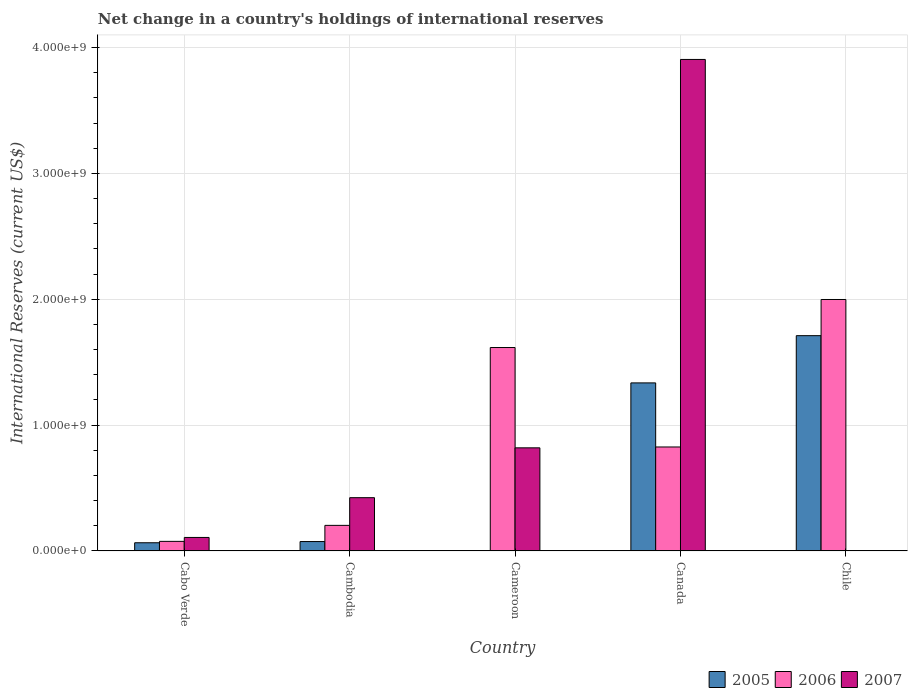How many different coloured bars are there?
Ensure brevity in your answer.  3. Are the number of bars per tick equal to the number of legend labels?
Provide a short and direct response. No. Are the number of bars on each tick of the X-axis equal?
Provide a succinct answer. No. How many bars are there on the 4th tick from the left?
Your answer should be compact. 3. How many bars are there on the 5th tick from the right?
Your answer should be compact. 3. What is the label of the 3rd group of bars from the left?
Your response must be concise. Cameroon. What is the international reserves in 2006 in Cabo Verde?
Your answer should be very brief. 7.60e+07. Across all countries, what is the maximum international reserves in 2005?
Offer a very short reply. 1.71e+09. Across all countries, what is the minimum international reserves in 2005?
Keep it short and to the point. 0. What is the total international reserves in 2005 in the graph?
Offer a very short reply. 3.19e+09. What is the difference between the international reserves in 2007 in Cambodia and that in Canada?
Keep it short and to the point. -3.48e+09. What is the difference between the international reserves in 2006 in Chile and the international reserves in 2007 in Canada?
Your answer should be very brief. -1.91e+09. What is the average international reserves in 2005 per country?
Your answer should be very brief. 6.37e+08. What is the difference between the international reserves of/in 2007 and international reserves of/in 2005 in Cambodia?
Give a very brief answer. 3.49e+08. In how many countries, is the international reserves in 2005 greater than 3800000000 US$?
Provide a short and direct response. 0. What is the ratio of the international reserves in 2006 in Canada to that in Chile?
Provide a short and direct response. 0.41. Is the international reserves in 2006 in Cabo Verde less than that in Chile?
Give a very brief answer. Yes. What is the difference between the highest and the second highest international reserves in 2006?
Give a very brief answer. 1.17e+09. What is the difference between the highest and the lowest international reserves in 2007?
Your answer should be compact. 3.91e+09. In how many countries, is the international reserves in 2006 greater than the average international reserves in 2006 taken over all countries?
Your response must be concise. 2. Is the sum of the international reserves in 2005 in Canada and Chile greater than the maximum international reserves in 2006 across all countries?
Offer a terse response. Yes. Is it the case that in every country, the sum of the international reserves in 2005 and international reserves in 2006 is greater than the international reserves in 2007?
Give a very brief answer. No. Where does the legend appear in the graph?
Your answer should be very brief. Bottom right. How many legend labels are there?
Your answer should be very brief. 3. How are the legend labels stacked?
Your answer should be compact. Horizontal. What is the title of the graph?
Offer a terse response. Net change in a country's holdings of international reserves. Does "1967" appear as one of the legend labels in the graph?
Offer a very short reply. No. What is the label or title of the Y-axis?
Offer a terse response. International Reserves (current US$). What is the International Reserves (current US$) in 2005 in Cabo Verde?
Your response must be concise. 6.49e+07. What is the International Reserves (current US$) in 2006 in Cabo Verde?
Your answer should be very brief. 7.60e+07. What is the International Reserves (current US$) of 2007 in Cabo Verde?
Your answer should be compact. 1.07e+08. What is the International Reserves (current US$) in 2005 in Cambodia?
Offer a very short reply. 7.45e+07. What is the International Reserves (current US$) in 2006 in Cambodia?
Your answer should be very brief. 2.03e+08. What is the International Reserves (current US$) of 2007 in Cambodia?
Keep it short and to the point. 4.23e+08. What is the International Reserves (current US$) of 2005 in Cameroon?
Keep it short and to the point. 0. What is the International Reserves (current US$) of 2006 in Cameroon?
Make the answer very short. 1.62e+09. What is the International Reserves (current US$) in 2007 in Cameroon?
Your response must be concise. 8.19e+08. What is the International Reserves (current US$) in 2005 in Canada?
Provide a short and direct response. 1.34e+09. What is the International Reserves (current US$) in 2006 in Canada?
Ensure brevity in your answer.  8.26e+08. What is the International Reserves (current US$) of 2007 in Canada?
Your response must be concise. 3.91e+09. What is the International Reserves (current US$) of 2005 in Chile?
Offer a very short reply. 1.71e+09. What is the International Reserves (current US$) in 2006 in Chile?
Ensure brevity in your answer.  2.00e+09. Across all countries, what is the maximum International Reserves (current US$) in 2005?
Make the answer very short. 1.71e+09. Across all countries, what is the maximum International Reserves (current US$) of 2006?
Your answer should be compact. 2.00e+09. Across all countries, what is the maximum International Reserves (current US$) of 2007?
Offer a very short reply. 3.91e+09. Across all countries, what is the minimum International Reserves (current US$) in 2006?
Make the answer very short. 7.60e+07. Across all countries, what is the minimum International Reserves (current US$) in 2007?
Give a very brief answer. 0. What is the total International Reserves (current US$) of 2005 in the graph?
Offer a very short reply. 3.19e+09. What is the total International Reserves (current US$) of 2006 in the graph?
Your response must be concise. 4.72e+09. What is the total International Reserves (current US$) of 2007 in the graph?
Offer a terse response. 5.26e+09. What is the difference between the International Reserves (current US$) of 2005 in Cabo Verde and that in Cambodia?
Offer a very short reply. -9.54e+06. What is the difference between the International Reserves (current US$) of 2006 in Cabo Verde and that in Cambodia?
Ensure brevity in your answer.  -1.27e+08. What is the difference between the International Reserves (current US$) in 2007 in Cabo Verde and that in Cambodia?
Your answer should be very brief. -3.16e+08. What is the difference between the International Reserves (current US$) of 2006 in Cabo Verde and that in Cameroon?
Provide a succinct answer. -1.54e+09. What is the difference between the International Reserves (current US$) in 2007 in Cabo Verde and that in Cameroon?
Your answer should be compact. -7.12e+08. What is the difference between the International Reserves (current US$) in 2005 in Cabo Verde and that in Canada?
Ensure brevity in your answer.  -1.27e+09. What is the difference between the International Reserves (current US$) of 2006 in Cabo Verde and that in Canada?
Your answer should be compact. -7.50e+08. What is the difference between the International Reserves (current US$) of 2007 in Cabo Verde and that in Canada?
Make the answer very short. -3.80e+09. What is the difference between the International Reserves (current US$) in 2005 in Cabo Verde and that in Chile?
Offer a terse response. -1.65e+09. What is the difference between the International Reserves (current US$) in 2006 in Cabo Verde and that in Chile?
Your answer should be very brief. -1.92e+09. What is the difference between the International Reserves (current US$) in 2006 in Cambodia and that in Cameroon?
Offer a terse response. -1.41e+09. What is the difference between the International Reserves (current US$) of 2007 in Cambodia and that in Cameroon?
Offer a very short reply. -3.96e+08. What is the difference between the International Reserves (current US$) of 2005 in Cambodia and that in Canada?
Offer a terse response. -1.26e+09. What is the difference between the International Reserves (current US$) in 2006 in Cambodia and that in Canada?
Your answer should be very brief. -6.23e+08. What is the difference between the International Reserves (current US$) of 2007 in Cambodia and that in Canada?
Give a very brief answer. -3.48e+09. What is the difference between the International Reserves (current US$) of 2005 in Cambodia and that in Chile?
Provide a succinct answer. -1.64e+09. What is the difference between the International Reserves (current US$) of 2006 in Cambodia and that in Chile?
Give a very brief answer. -1.80e+09. What is the difference between the International Reserves (current US$) of 2006 in Cameroon and that in Canada?
Provide a succinct answer. 7.90e+08. What is the difference between the International Reserves (current US$) in 2007 in Cameroon and that in Canada?
Make the answer very short. -3.09e+09. What is the difference between the International Reserves (current US$) in 2006 in Cameroon and that in Chile?
Your answer should be compact. -3.82e+08. What is the difference between the International Reserves (current US$) of 2005 in Canada and that in Chile?
Your response must be concise. -3.75e+08. What is the difference between the International Reserves (current US$) in 2006 in Canada and that in Chile?
Your answer should be very brief. -1.17e+09. What is the difference between the International Reserves (current US$) of 2005 in Cabo Verde and the International Reserves (current US$) of 2006 in Cambodia?
Keep it short and to the point. -1.38e+08. What is the difference between the International Reserves (current US$) in 2005 in Cabo Verde and the International Reserves (current US$) in 2007 in Cambodia?
Offer a very short reply. -3.58e+08. What is the difference between the International Reserves (current US$) of 2006 in Cabo Verde and the International Reserves (current US$) of 2007 in Cambodia?
Offer a terse response. -3.47e+08. What is the difference between the International Reserves (current US$) in 2005 in Cabo Verde and the International Reserves (current US$) in 2006 in Cameroon?
Make the answer very short. -1.55e+09. What is the difference between the International Reserves (current US$) in 2005 in Cabo Verde and the International Reserves (current US$) in 2007 in Cameroon?
Give a very brief answer. -7.54e+08. What is the difference between the International Reserves (current US$) in 2006 in Cabo Verde and the International Reserves (current US$) in 2007 in Cameroon?
Provide a succinct answer. -7.43e+08. What is the difference between the International Reserves (current US$) in 2005 in Cabo Verde and the International Reserves (current US$) in 2006 in Canada?
Offer a very short reply. -7.61e+08. What is the difference between the International Reserves (current US$) in 2005 in Cabo Verde and the International Reserves (current US$) in 2007 in Canada?
Ensure brevity in your answer.  -3.84e+09. What is the difference between the International Reserves (current US$) in 2006 in Cabo Verde and the International Reserves (current US$) in 2007 in Canada?
Your answer should be compact. -3.83e+09. What is the difference between the International Reserves (current US$) of 2005 in Cabo Verde and the International Reserves (current US$) of 2006 in Chile?
Your response must be concise. -1.93e+09. What is the difference between the International Reserves (current US$) in 2005 in Cambodia and the International Reserves (current US$) in 2006 in Cameroon?
Offer a very short reply. -1.54e+09. What is the difference between the International Reserves (current US$) of 2005 in Cambodia and the International Reserves (current US$) of 2007 in Cameroon?
Keep it short and to the point. -7.45e+08. What is the difference between the International Reserves (current US$) in 2006 in Cambodia and the International Reserves (current US$) in 2007 in Cameroon?
Keep it short and to the point. -6.16e+08. What is the difference between the International Reserves (current US$) of 2005 in Cambodia and the International Reserves (current US$) of 2006 in Canada?
Make the answer very short. -7.52e+08. What is the difference between the International Reserves (current US$) in 2005 in Cambodia and the International Reserves (current US$) in 2007 in Canada?
Offer a very short reply. -3.83e+09. What is the difference between the International Reserves (current US$) in 2006 in Cambodia and the International Reserves (current US$) in 2007 in Canada?
Keep it short and to the point. -3.70e+09. What is the difference between the International Reserves (current US$) of 2005 in Cambodia and the International Reserves (current US$) of 2006 in Chile?
Your answer should be very brief. -1.92e+09. What is the difference between the International Reserves (current US$) in 2006 in Cameroon and the International Reserves (current US$) in 2007 in Canada?
Your answer should be compact. -2.29e+09. What is the difference between the International Reserves (current US$) of 2005 in Canada and the International Reserves (current US$) of 2006 in Chile?
Provide a short and direct response. -6.63e+08. What is the average International Reserves (current US$) of 2005 per country?
Give a very brief answer. 6.37e+08. What is the average International Reserves (current US$) in 2006 per country?
Make the answer very short. 9.44e+08. What is the average International Reserves (current US$) of 2007 per country?
Provide a succinct answer. 1.05e+09. What is the difference between the International Reserves (current US$) of 2005 and International Reserves (current US$) of 2006 in Cabo Verde?
Provide a short and direct response. -1.10e+07. What is the difference between the International Reserves (current US$) of 2005 and International Reserves (current US$) of 2007 in Cabo Verde?
Give a very brief answer. -4.22e+07. What is the difference between the International Reserves (current US$) in 2006 and International Reserves (current US$) in 2007 in Cabo Verde?
Give a very brief answer. -3.12e+07. What is the difference between the International Reserves (current US$) of 2005 and International Reserves (current US$) of 2006 in Cambodia?
Offer a very short reply. -1.29e+08. What is the difference between the International Reserves (current US$) of 2005 and International Reserves (current US$) of 2007 in Cambodia?
Provide a succinct answer. -3.49e+08. What is the difference between the International Reserves (current US$) in 2006 and International Reserves (current US$) in 2007 in Cambodia?
Your answer should be very brief. -2.20e+08. What is the difference between the International Reserves (current US$) of 2006 and International Reserves (current US$) of 2007 in Cameroon?
Your response must be concise. 7.97e+08. What is the difference between the International Reserves (current US$) of 2005 and International Reserves (current US$) of 2006 in Canada?
Give a very brief answer. 5.09e+08. What is the difference between the International Reserves (current US$) in 2005 and International Reserves (current US$) in 2007 in Canada?
Ensure brevity in your answer.  -2.57e+09. What is the difference between the International Reserves (current US$) of 2006 and International Reserves (current US$) of 2007 in Canada?
Your answer should be very brief. -3.08e+09. What is the difference between the International Reserves (current US$) in 2005 and International Reserves (current US$) in 2006 in Chile?
Your answer should be very brief. -2.88e+08. What is the ratio of the International Reserves (current US$) of 2005 in Cabo Verde to that in Cambodia?
Provide a succinct answer. 0.87. What is the ratio of the International Reserves (current US$) in 2006 in Cabo Verde to that in Cambodia?
Keep it short and to the point. 0.37. What is the ratio of the International Reserves (current US$) of 2007 in Cabo Verde to that in Cambodia?
Offer a terse response. 0.25. What is the ratio of the International Reserves (current US$) of 2006 in Cabo Verde to that in Cameroon?
Keep it short and to the point. 0.05. What is the ratio of the International Reserves (current US$) in 2007 in Cabo Verde to that in Cameroon?
Offer a very short reply. 0.13. What is the ratio of the International Reserves (current US$) in 2005 in Cabo Verde to that in Canada?
Provide a short and direct response. 0.05. What is the ratio of the International Reserves (current US$) of 2006 in Cabo Verde to that in Canada?
Offer a terse response. 0.09. What is the ratio of the International Reserves (current US$) of 2007 in Cabo Verde to that in Canada?
Offer a very short reply. 0.03. What is the ratio of the International Reserves (current US$) of 2005 in Cabo Verde to that in Chile?
Ensure brevity in your answer.  0.04. What is the ratio of the International Reserves (current US$) of 2006 in Cabo Verde to that in Chile?
Offer a terse response. 0.04. What is the ratio of the International Reserves (current US$) in 2006 in Cambodia to that in Cameroon?
Your response must be concise. 0.13. What is the ratio of the International Reserves (current US$) of 2007 in Cambodia to that in Cameroon?
Your response must be concise. 0.52. What is the ratio of the International Reserves (current US$) in 2005 in Cambodia to that in Canada?
Offer a terse response. 0.06. What is the ratio of the International Reserves (current US$) of 2006 in Cambodia to that in Canada?
Offer a very short reply. 0.25. What is the ratio of the International Reserves (current US$) of 2007 in Cambodia to that in Canada?
Offer a terse response. 0.11. What is the ratio of the International Reserves (current US$) of 2005 in Cambodia to that in Chile?
Provide a short and direct response. 0.04. What is the ratio of the International Reserves (current US$) of 2006 in Cambodia to that in Chile?
Keep it short and to the point. 0.1. What is the ratio of the International Reserves (current US$) of 2006 in Cameroon to that in Canada?
Your answer should be compact. 1.96. What is the ratio of the International Reserves (current US$) of 2007 in Cameroon to that in Canada?
Provide a succinct answer. 0.21. What is the ratio of the International Reserves (current US$) of 2006 in Cameroon to that in Chile?
Your answer should be very brief. 0.81. What is the ratio of the International Reserves (current US$) in 2005 in Canada to that in Chile?
Make the answer very short. 0.78. What is the ratio of the International Reserves (current US$) in 2006 in Canada to that in Chile?
Make the answer very short. 0.41. What is the difference between the highest and the second highest International Reserves (current US$) in 2005?
Offer a very short reply. 3.75e+08. What is the difference between the highest and the second highest International Reserves (current US$) of 2006?
Offer a terse response. 3.82e+08. What is the difference between the highest and the second highest International Reserves (current US$) in 2007?
Offer a terse response. 3.09e+09. What is the difference between the highest and the lowest International Reserves (current US$) of 2005?
Ensure brevity in your answer.  1.71e+09. What is the difference between the highest and the lowest International Reserves (current US$) in 2006?
Offer a very short reply. 1.92e+09. What is the difference between the highest and the lowest International Reserves (current US$) in 2007?
Ensure brevity in your answer.  3.91e+09. 